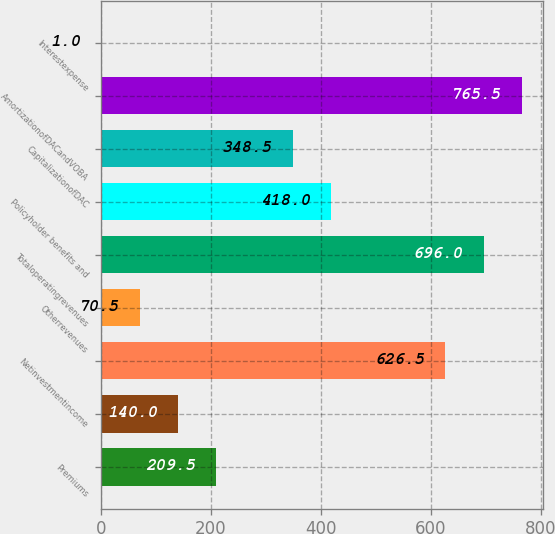<chart> <loc_0><loc_0><loc_500><loc_500><bar_chart><fcel>Premiums<fcel>Unnamed: 1<fcel>Netinvestmentincome<fcel>Otherrevenues<fcel>Totaloperatingrevenues<fcel>Policyholder benefits and<fcel>CapitalizationofDAC<fcel>AmortizationofDACandVOBA<fcel>Interestexpense<nl><fcel>209.5<fcel>140<fcel>626.5<fcel>70.5<fcel>696<fcel>418<fcel>348.5<fcel>765.5<fcel>1<nl></chart> 